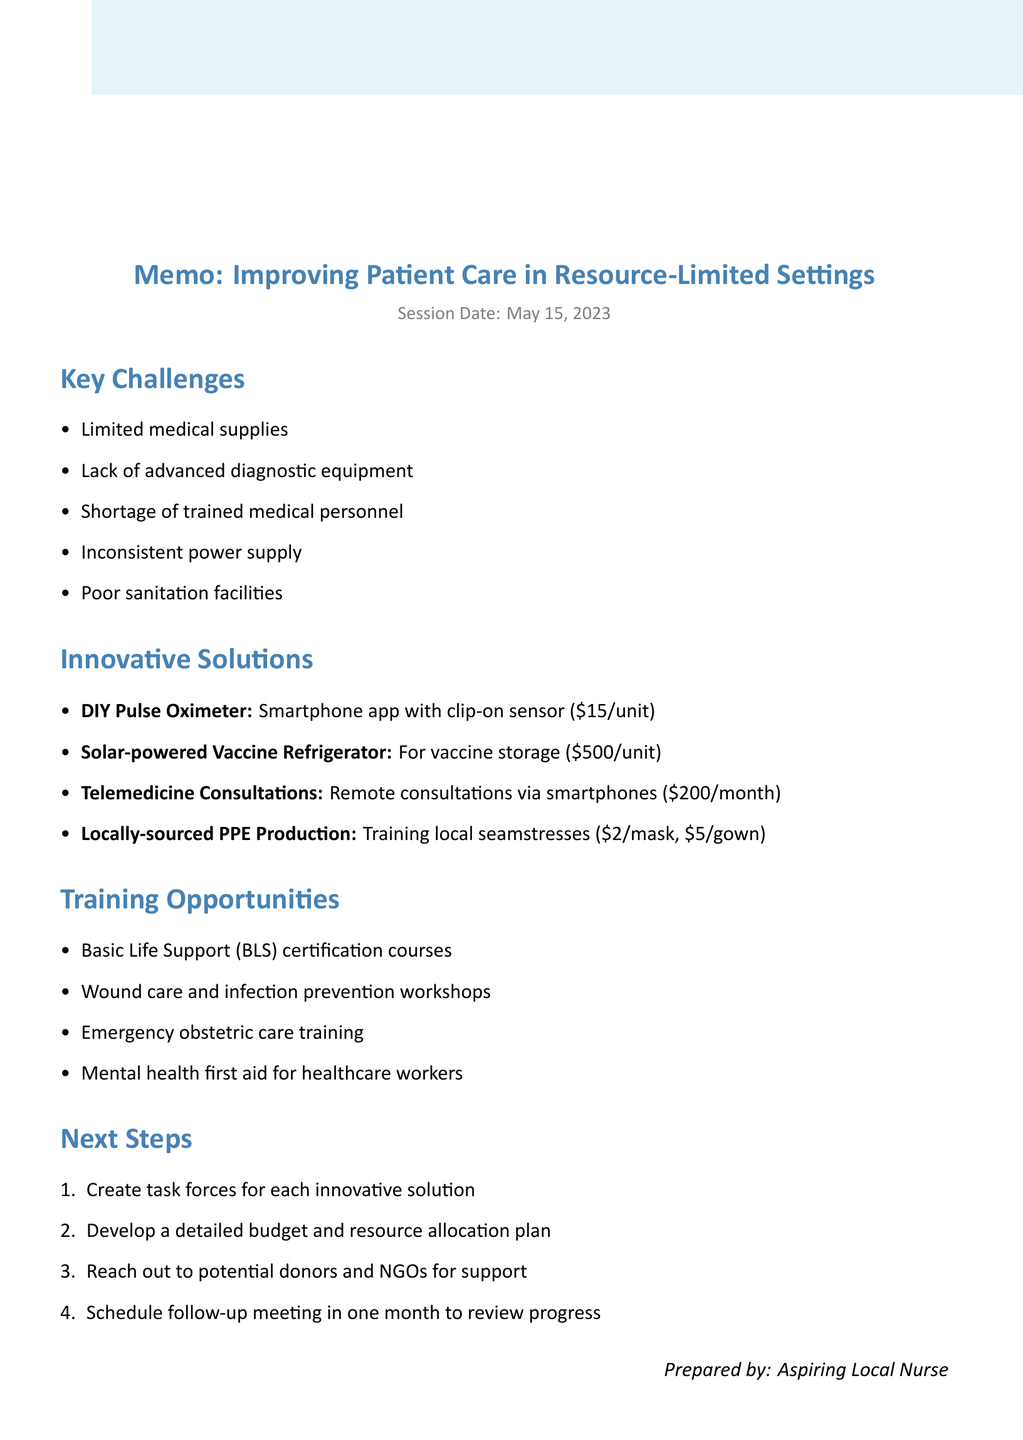What is the date of the session? The date of the session is explicitly stated in the document as May 15, 2023.
Answer: May 15, 2023 Who is the Chief of Medicine present in the session? The Chief of Medicine is listed among the session participants, which identifies them as Dr. Sarah Nguyen.
Answer: Dr. Sarah Nguyen What estimated cost is associated with the DIY Pulse Oximeter? The estimated cost for the DIY Pulse Oximeter is included in the innovative solutions section of the document.
Answer: $15 per unit What is one of the key challenges mentioned in the memo? The memo lists several key challenges, one of which must be identified from that list.
Answer: Limited medical supplies How many innovative solutions are proposed in the memo? The document explicitly lists the innovative solutions, allowing for a simple count of the items mentioned.
Answer: Four What training opportunity is focused on mental health for healthcare workers? The training opportunities section lists mental health first aid as a specific program for healthcare workers.
Answer: Mental health first aid for healthcare workers What is the main purpose of the next steps section? The next steps section provides actionable items to improve patient care after discussion in the session, requiring synthesis of this intention.
Answer: Create task forces for each innovative solution What is one community engagement idea mentioned in the memo? One community engagement idea is highlighted in the document, which allows for the identification of an initiative from the list provided.
Answer: Health education programs in local schools 